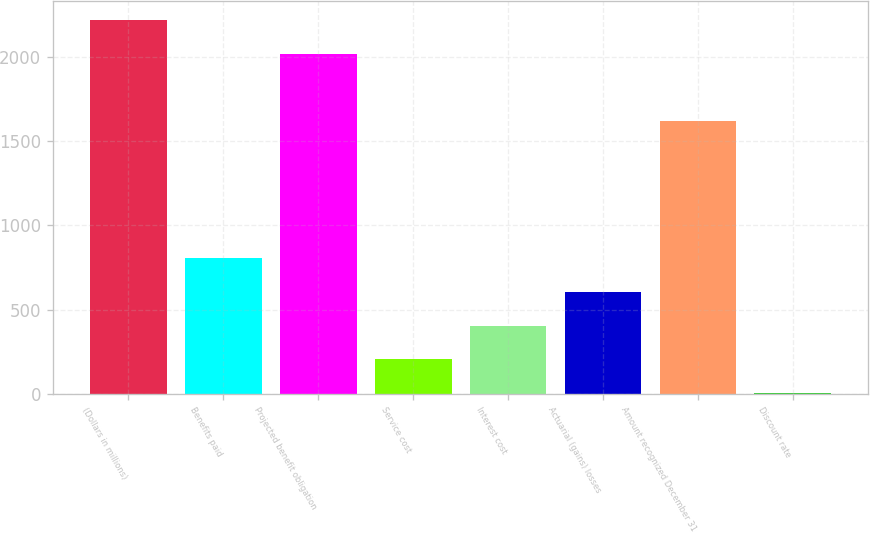Convert chart to OTSL. <chart><loc_0><loc_0><loc_500><loc_500><bar_chart><fcel>(Dollars in millions)<fcel>Benefits paid<fcel>Projected benefit obligation<fcel>Service cost<fcel>Interest cost<fcel>Actuarial (gains) losses<fcel>Amount recognized December 31<fcel>Discount rate<nl><fcel>2220.11<fcel>805.87<fcel>2020.09<fcel>205.78<fcel>405.81<fcel>605.84<fcel>1620.03<fcel>5.75<nl></chart> 